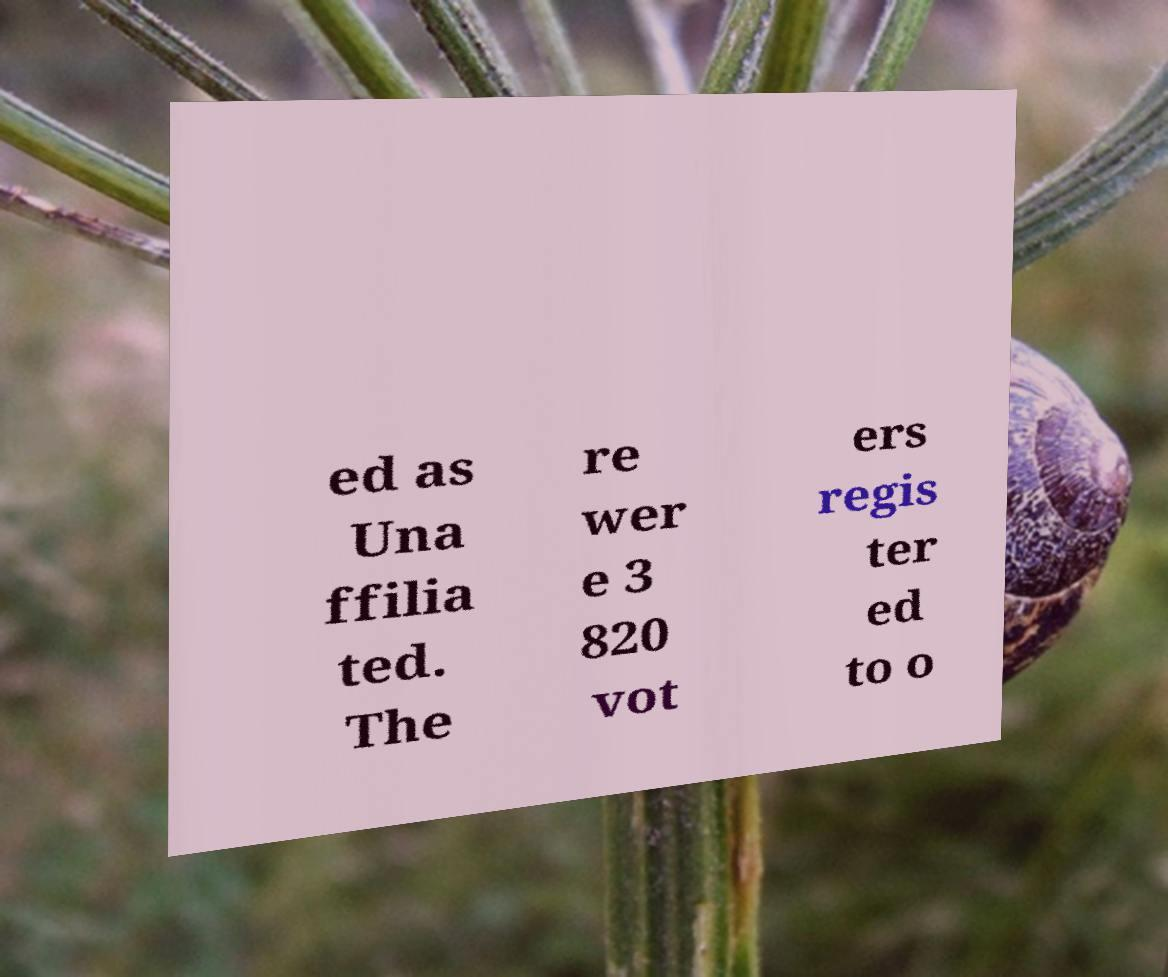There's text embedded in this image that I need extracted. Can you transcribe it verbatim? ed as Una ffilia ted. The re wer e 3 820 vot ers regis ter ed to o 